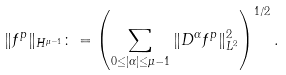<formula> <loc_0><loc_0><loc_500><loc_500>\| f ^ { p } \| _ { H ^ { \mu - 1 } } \colon = \left ( \sum _ { 0 \leq | \alpha | \leq \mu - 1 } \| D ^ { \alpha } f ^ { p } \| _ { L ^ { 2 } } ^ { 2 } \right ) ^ { 1 / 2 } .</formula> 